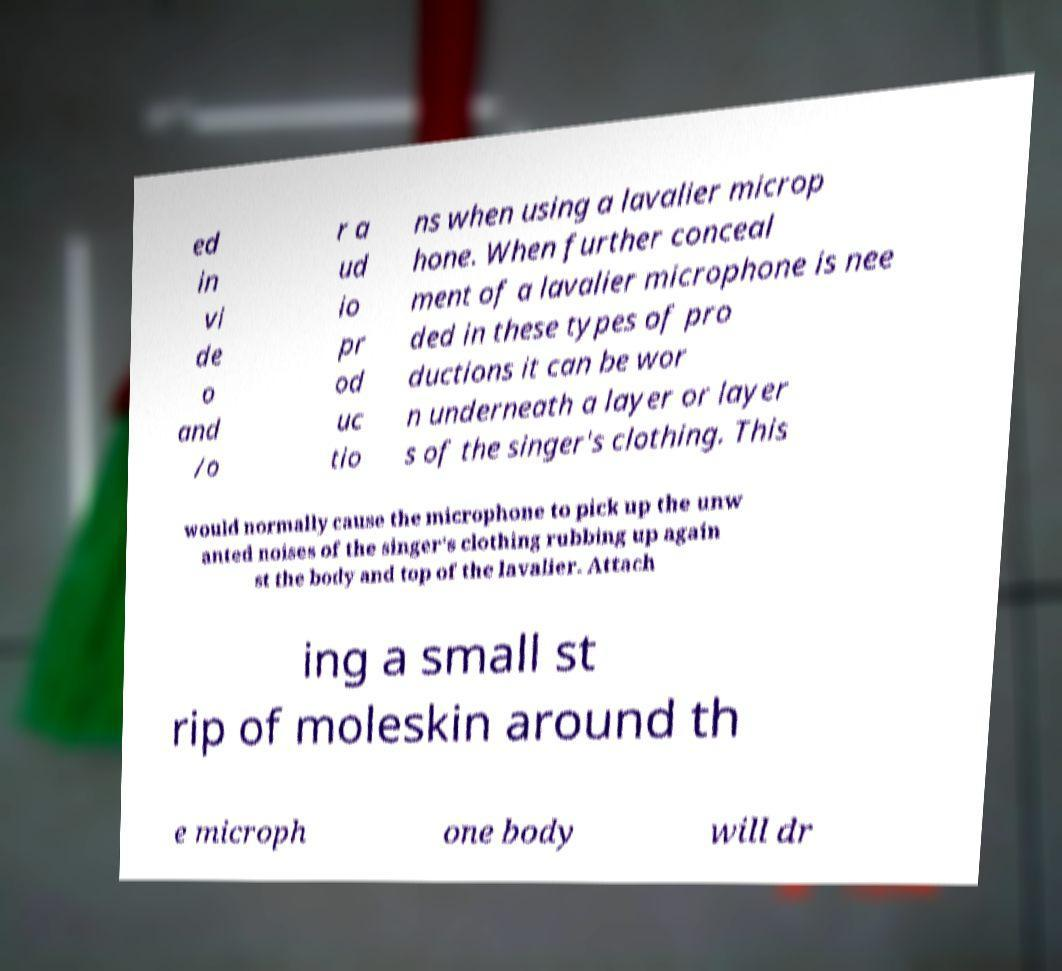There's text embedded in this image that I need extracted. Can you transcribe it verbatim? ed in vi de o and /o r a ud io pr od uc tio ns when using a lavalier microp hone. When further conceal ment of a lavalier microphone is nee ded in these types of pro ductions it can be wor n underneath a layer or layer s of the singer's clothing. This would normally cause the microphone to pick up the unw anted noises of the singer's clothing rubbing up again st the body and top of the lavalier. Attach ing a small st rip of moleskin around th e microph one body will dr 